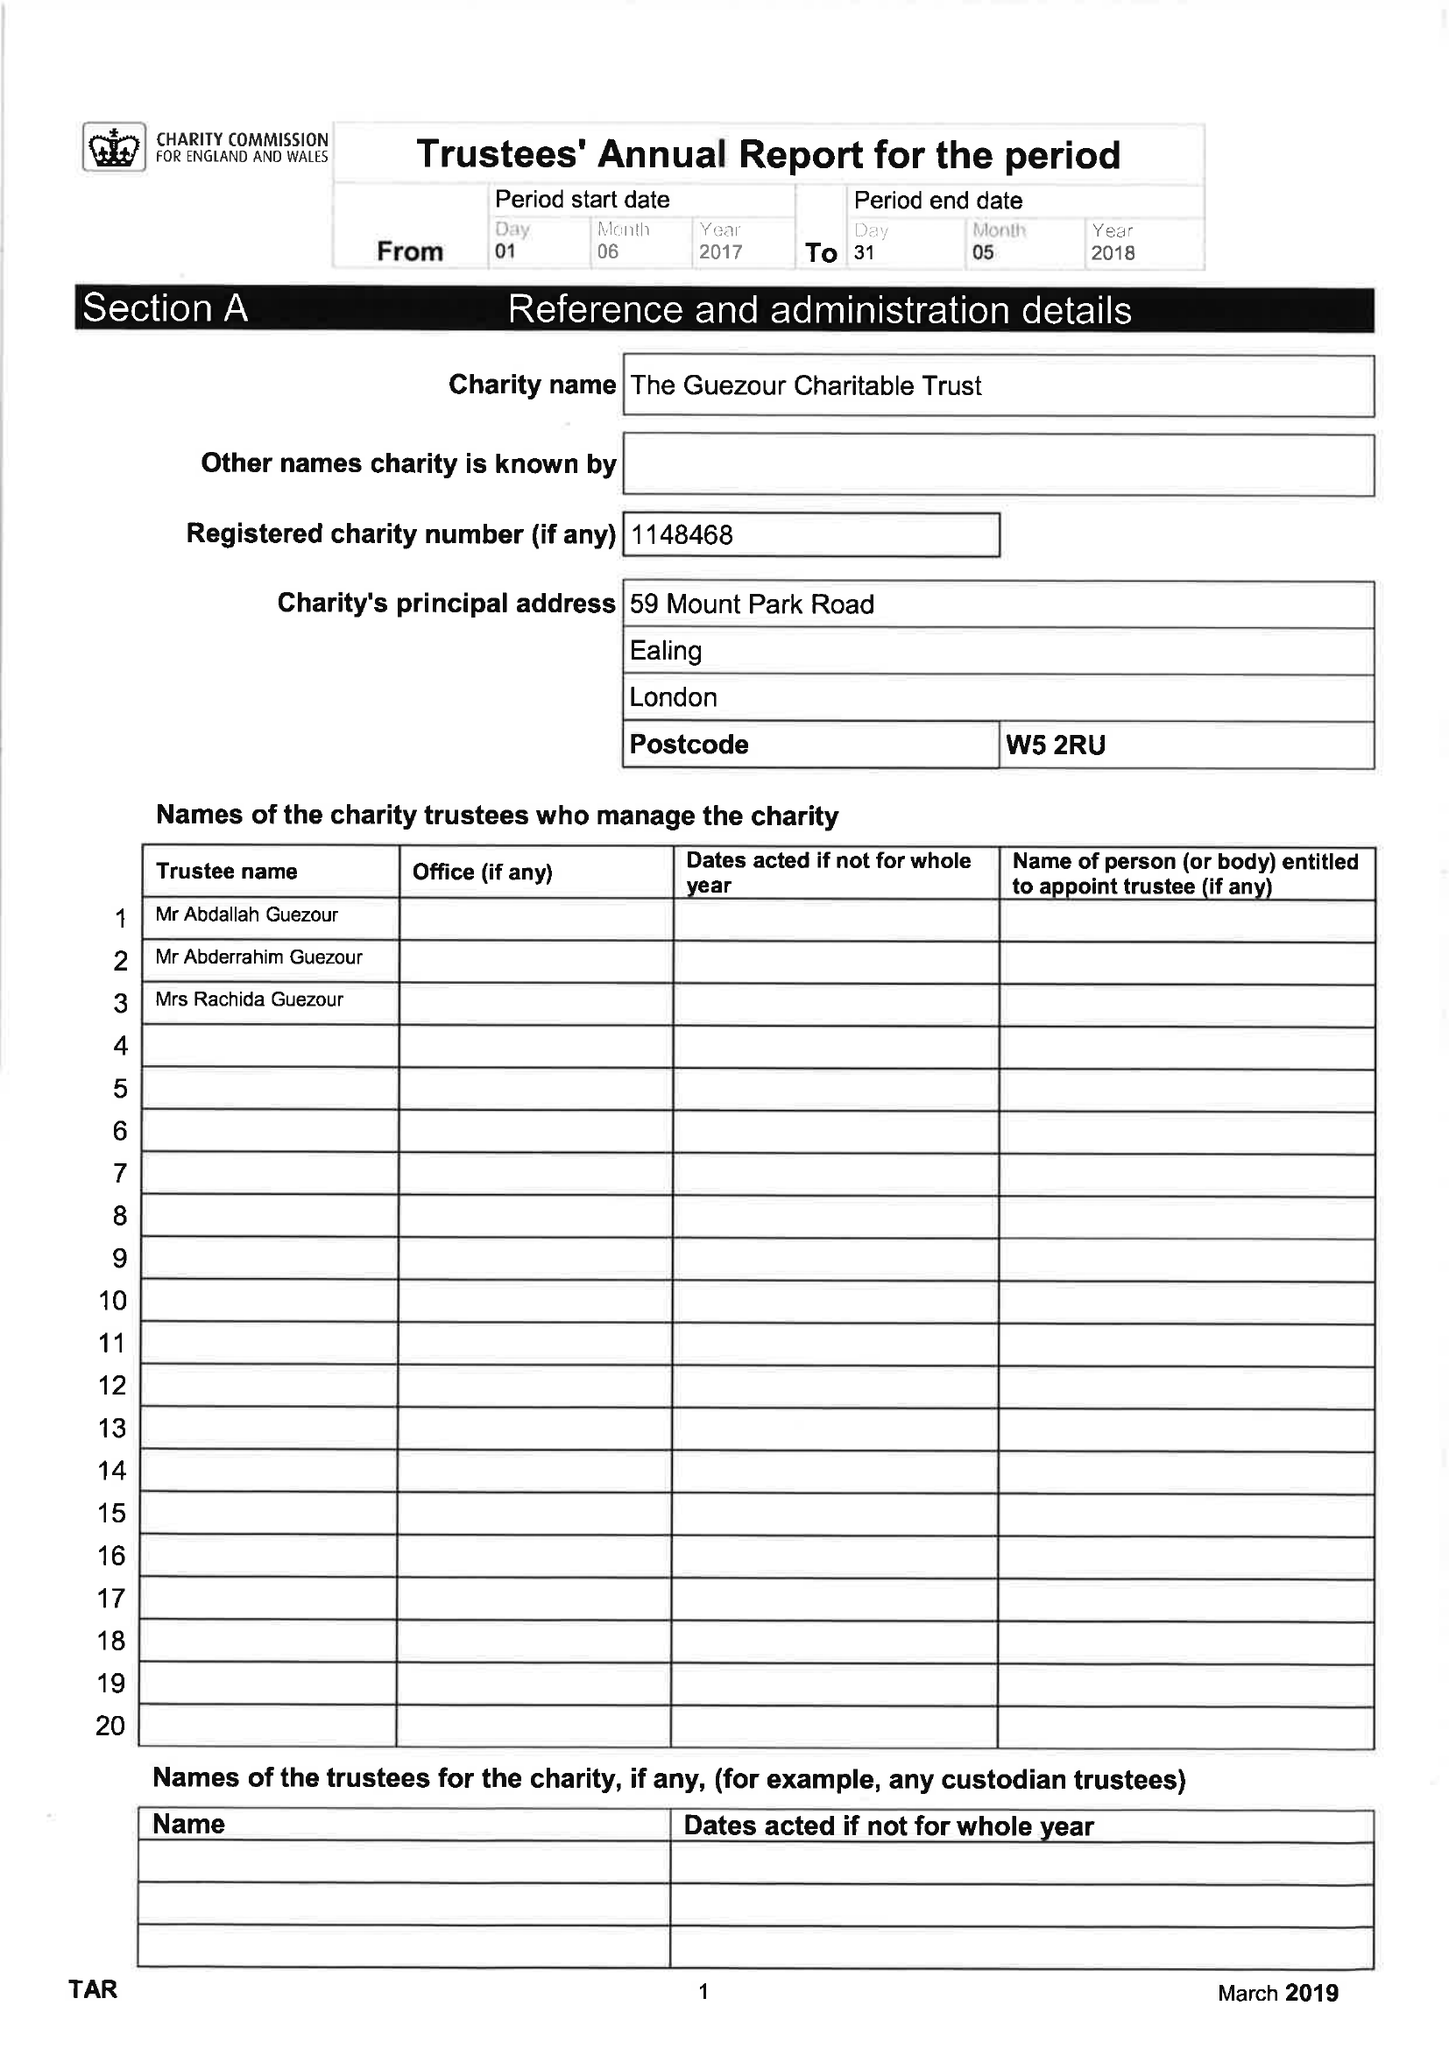What is the value for the spending_annually_in_british_pounds?
Answer the question using a single word or phrase. 252006.00 